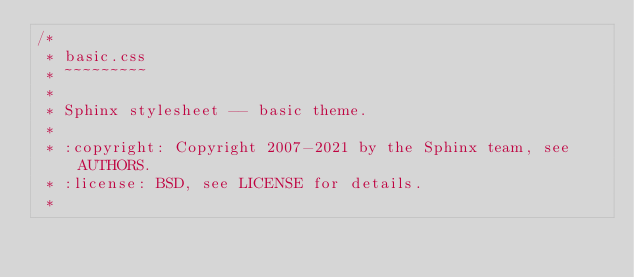<code> <loc_0><loc_0><loc_500><loc_500><_CSS_>/*
 * basic.css
 * ~~~~~~~~~
 *
 * Sphinx stylesheet -- basic theme.
 *
 * :copyright: Copyright 2007-2021 by the Sphinx team, see AUTHORS.
 * :license: BSD, see LICENSE for details.
 *</code> 